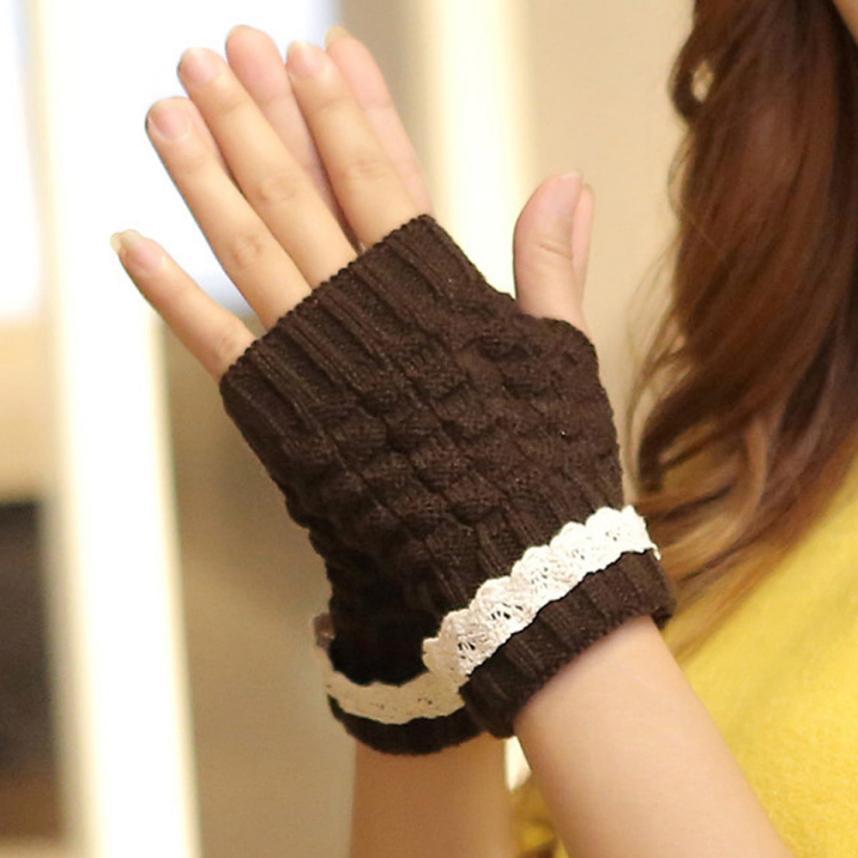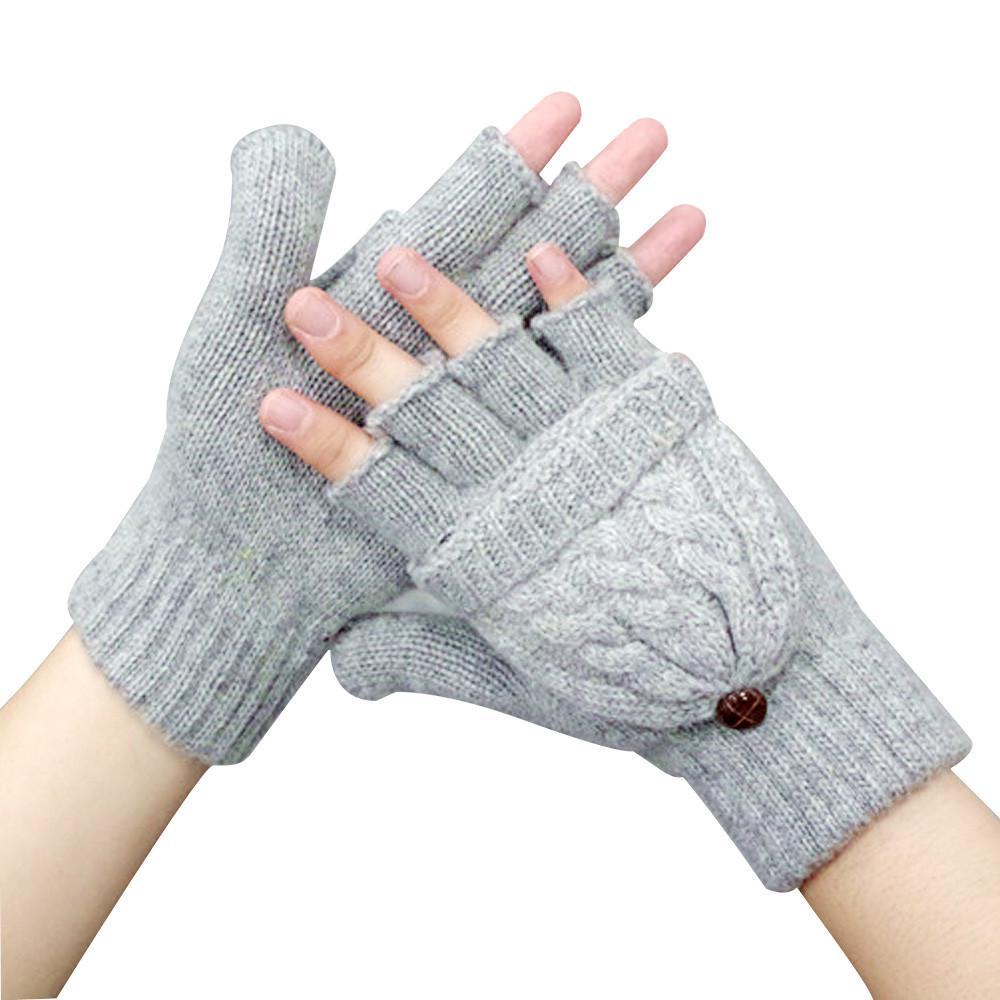The first image is the image on the left, the second image is the image on the right. Considering the images on both sides, is "There are a total of 2 hand models present wearing gloves." valid? Answer yes or no. Yes. The first image is the image on the left, the second image is the image on the right. Considering the images on both sides, is "There's a set of gloves that are not being worn." valid? Answer yes or no. No. 